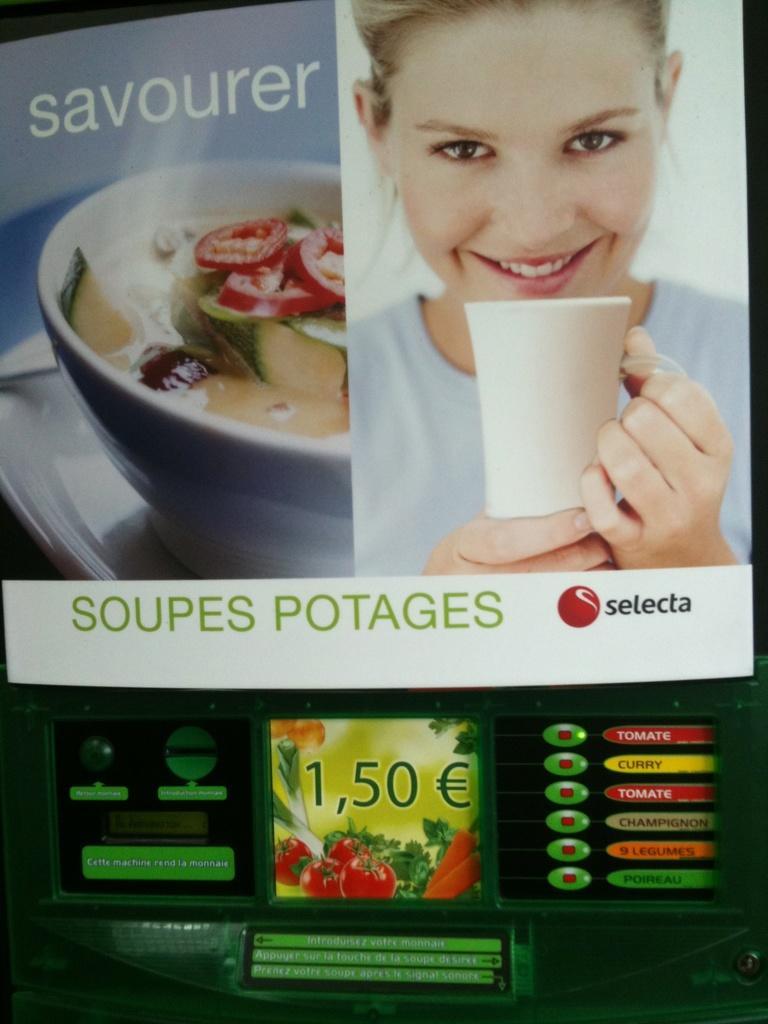Could you give a brief overview of what you see in this image? This image consists of a poster. On this poster, I can see a woman holding a glass in the hand, smiling and looking at the picture and also there is a bowl which consists of some food. Here I can see some text. 